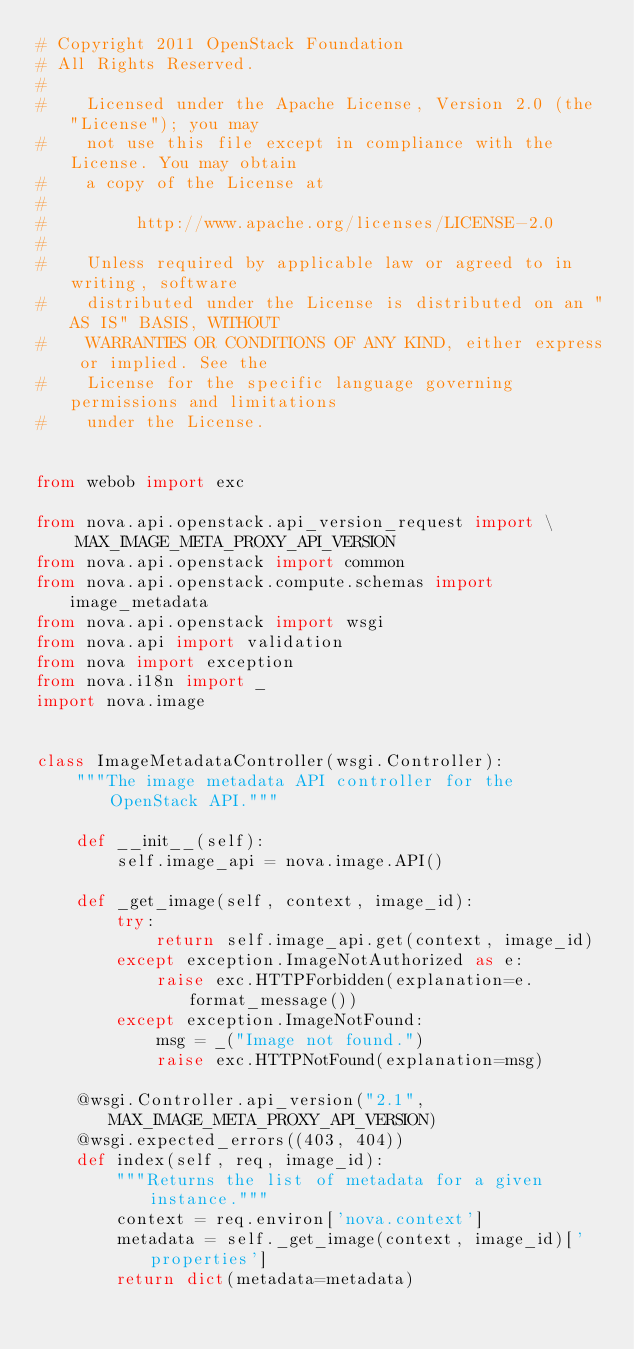Convert code to text. <code><loc_0><loc_0><loc_500><loc_500><_Python_># Copyright 2011 OpenStack Foundation
# All Rights Reserved.
#
#    Licensed under the Apache License, Version 2.0 (the "License"); you may
#    not use this file except in compliance with the License. You may obtain
#    a copy of the License at
#
#         http://www.apache.org/licenses/LICENSE-2.0
#
#    Unless required by applicable law or agreed to in writing, software
#    distributed under the License is distributed on an "AS IS" BASIS, WITHOUT
#    WARRANTIES OR CONDITIONS OF ANY KIND, either express or implied. See the
#    License for the specific language governing permissions and limitations
#    under the License.


from webob import exc

from nova.api.openstack.api_version_request import \
    MAX_IMAGE_META_PROXY_API_VERSION
from nova.api.openstack import common
from nova.api.openstack.compute.schemas import image_metadata
from nova.api.openstack import wsgi
from nova.api import validation
from nova import exception
from nova.i18n import _
import nova.image


class ImageMetadataController(wsgi.Controller):
    """The image metadata API controller for the OpenStack API."""

    def __init__(self):
        self.image_api = nova.image.API()

    def _get_image(self, context, image_id):
        try:
            return self.image_api.get(context, image_id)
        except exception.ImageNotAuthorized as e:
            raise exc.HTTPForbidden(explanation=e.format_message())
        except exception.ImageNotFound:
            msg = _("Image not found.")
            raise exc.HTTPNotFound(explanation=msg)

    @wsgi.Controller.api_version("2.1", MAX_IMAGE_META_PROXY_API_VERSION)
    @wsgi.expected_errors((403, 404))
    def index(self, req, image_id):
        """Returns the list of metadata for a given instance."""
        context = req.environ['nova.context']
        metadata = self._get_image(context, image_id)['properties']
        return dict(metadata=metadata)
</code> 